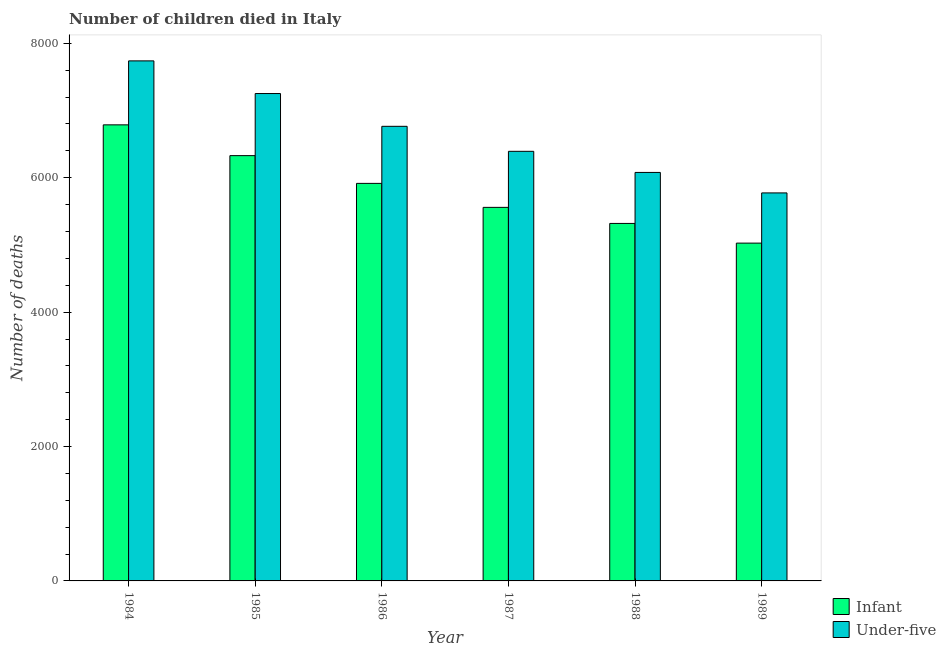How many groups of bars are there?
Offer a very short reply. 6. Are the number of bars per tick equal to the number of legend labels?
Give a very brief answer. Yes. Are the number of bars on each tick of the X-axis equal?
Provide a short and direct response. Yes. What is the label of the 1st group of bars from the left?
Your answer should be very brief. 1984. What is the number of infant deaths in 1989?
Your response must be concise. 5027. Across all years, what is the maximum number of infant deaths?
Offer a terse response. 6787. Across all years, what is the minimum number of under-five deaths?
Your answer should be very brief. 5774. In which year was the number of under-five deaths maximum?
Provide a succinct answer. 1984. In which year was the number of infant deaths minimum?
Your response must be concise. 1989. What is the total number of infant deaths in the graph?
Your response must be concise. 3.49e+04. What is the difference between the number of infant deaths in 1986 and that in 1988?
Offer a terse response. 596. What is the difference between the number of infant deaths in 1985 and the number of under-five deaths in 1986?
Offer a very short reply. 413. What is the average number of infant deaths per year?
Offer a very short reply. 5823. In how many years, is the number of infant deaths greater than 5200?
Provide a short and direct response. 5. What is the ratio of the number of under-five deaths in 1987 to that in 1989?
Provide a succinct answer. 1.11. Is the number of infant deaths in 1988 less than that in 1989?
Ensure brevity in your answer.  No. What is the difference between the highest and the second highest number of infant deaths?
Provide a succinct answer. 458. What is the difference between the highest and the lowest number of infant deaths?
Your response must be concise. 1760. What does the 2nd bar from the left in 1984 represents?
Your answer should be very brief. Under-five. What does the 1st bar from the right in 1989 represents?
Offer a very short reply. Under-five. How many bars are there?
Give a very brief answer. 12. Does the graph contain any zero values?
Your answer should be very brief. No. Where does the legend appear in the graph?
Make the answer very short. Bottom right. How many legend labels are there?
Your answer should be very brief. 2. What is the title of the graph?
Offer a very short reply. Number of children died in Italy. What is the label or title of the X-axis?
Make the answer very short. Year. What is the label or title of the Y-axis?
Provide a succinct answer. Number of deaths. What is the Number of deaths of Infant in 1984?
Keep it short and to the point. 6787. What is the Number of deaths of Under-five in 1984?
Offer a terse response. 7739. What is the Number of deaths of Infant in 1985?
Make the answer very short. 6329. What is the Number of deaths of Under-five in 1985?
Give a very brief answer. 7253. What is the Number of deaths in Infant in 1986?
Offer a terse response. 5916. What is the Number of deaths in Under-five in 1986?
Offer a terse response. 6765. What is the Number of deaths in Infant in 1987?
Ensure brevity in your answer.  5559. What is the Number of deaths of Under-five in 1987?
Your answer should be compact. 6393. What is the Number of deaths of Infant in 1988?
Offer a terse response. 5320. What is the Number of deaths of Under-five in 1988?
Give a very brief answer. 6079. What is the Number of deaths in Infant in 1989?
Offer a very short reply. 5027. What is the Number of deaths of Under-five in 1989?
Provide a succinct answer. 5774. Across all years, what is the maximum Number of deaths in Infant?
Provide a succinct answer. 6787. Across all years, what is the maximum Number of deaths in Under-five?
Your response must be concise. 7739. Across all years, what is the minimum Number of deaths of Infant?
Give a very brief answer. 5027. Across all years, what is the minimum Number of deaths of Under-five?
Your answer should be very brief. 5774. What is the total Number of deaths of Infant in the graph?
Your answer should be compact. 3.49e+04. What is the total Number of deaths of Under-five in the graph?
Ensure brevity in your answer.  4.00e+04. What is the difference between the Number of deaths of Infant in 1984 and that in 1985?
Keep it short and to the point. 458. What is the difference between the Number of deaths in Under-five in 1984 and that in 1985?
Ensure brevity in your answer.  486. What is the difference between the Number of deaths in Infant in 1984 and that in 1986?
Give a very brief answer. 871. What is the difference between the Number of deaths of Under-five in 1984 and that in 1986?
Keep it short and to the point. 974. What is the difference between the Number of deaths in Infant in 1984 and that in 1987?
Keep it short and to the point. 1228. What is the difference between the Number of deaths of Under-five in 1984 and that in 1987?
Offer a terse response. 1346. What is the difference between the Number of deaths of Infant in 1984 and that in 1988?
Provide a succinct answer. 1467. What is the difference between the Number of deaths of Under-five in 1984 and that in 1988?
Give a very brief answer. 1660. What is the difference between the Number of deaths of Infant in 1984 and that in 1989?
Offer a very short reply. 1760. What is the difference between the Number of deaths in Under-five in 1984 and that in 1989?
Make the answer very short. 1965. What is the difference between the Number of deaths of Infant in 1985 and that in 1986?
Make the answer very short. 413. What is the difference between the Number of deaths of Under-five in 1985 and that in 1986?
Offer a very short reply. 488. What is the difference between the Number of deaths of Infant in 1985 and that in 1987?
Offer a very short reply. 770. What is the difference between the Number of deaths of Under-five in 1985 and that in 1987?
Give a very brief answer. 860. What is the difference between the Number of deaths of Infant in 1985 and that in 1988?
Offer a very short reply. 1009. What is the difference between the Number of deaths of Under-five in 1985 and that in 1988?
Give a very brief answer. 1174. What is the difference between the Number of deaths of Infant in 1985 and that in 1989?
Provide a short and direct response. 1302. What is the difference between the Number of deaths in Under-five in 1985 and that in 1989?
Your response must be concise. 1479. What is the difference between the Number of deaths of Infant in 1986 and that in 1987?
Your answer should be very brief. 357. What is the difference between the Number of deaths in Under-five in 1986 and that in 1987?
Keep it short and to the point. 372. What is the difference between the Number of deaths in Infant in 1986 and that in 1988?
Offer a very short reply. 596. What is the difference between the Number of deaths in Under-five in 1986 and that in 1988?
Ensure brevity in your answer.  686. What is the difference between the Number of deaths of Infant in 1986 and that in 1989?
Your response must be concise. 889. What is the difference between the Number of deaths in Under-five in 1986 and that in 1989?
Make the answer very short. 991. What is the difference between the Number of deaths in Infant in 1987 and that in 1988?
Keep it short and to the point. 239. What is the difference between the Number of deaths in Under-five in 1987 and that in 1988?
Your answer should be very brief. 314. What is the difference between the Number of deaths in Infant in 1987 and that in 1989?
Your answer should be compact. 532. What is the difference between the Number of deaths in Under-five in 1987 and that in 1989?
Offer a terse response. 619. What is the difference between the Number of deaths of Infant in 1988 and that in 1989?
Make the answer very short. 293. What is the difference between the Number of deaths in Under-five in 1988 and that in 1989?
Your response must be concise. 305. What is the difference between the Number of deaths in Infant in 1984 and the Number of deaths in Under-five in 1985?
Offer a very short reply. -466. What is the difference between the Number of deaths in Infant in 1984 and the Number of deaths in Under-five in 1987?
Your answer should be compact. 394. What is the difference between the Number of deaths in Infant in 1984 and the Number of deaths in Under-five in 1988?
Your response must be concise. 708. What is the difference between the Number of deaths in Infant in 1984 and the Number of deaths in Under-five in 1989?
Ensure brevity in your answer.  1013. What is the difference between the Number of deaths of Infant in 1985 and the Number of deaths of Under-five in 1986?
Give a very brief answer. -436. What is the difference between the Number of deaths in Infant in 1985 and the Number of deaths in Under-five in 1987?
Your answer should be very brief. -64. What is the difference between the Number of deaths in Infant in 1985 and the Number of deaths in Under-five in 1988?
Offer a terse response. 250. What is the difference between the Number of deaths in Infant in 1985 and the Number of deaths in Under-five in 1989?
Your answer should be very brief. 555. What is the difference between the Number of deaths in Infant in 1986 and the Number of deaths in Under-five in 1987?
Your answer should be compact. -477. What is the difference between the Number of deaths of Infant in 1986 and the Number of deaths of Under-five in 1988?
Ensure brevity in your answer.  -163. What is the difference between the Number of deaths of Infant in 1986 and the Number of deaths of Under-five in 1989?
Provide a short and direct response. 142. What is the difference between the Number of deaths in Infant in 1987 and the Number of deaths in Under-five in 1988?
Offer a very short reply. -520. What is the difference between the Number of deaths of Infant in 1987 and the Number of deaths of Under-five in 1989?
Your answer should be compact. -215. What is the difference between the Number of deaths of Infant in 1988 and the Number of deaths of Under-five in 1989?
Your answer should be compact. -454. What is the average Number of deaths of Infant per year?
Your response must be concise. 5823. What is the average Number of deaths in Under-five per year?
Offer a very short reply. 6667.17. In the year 1984, what is the difference between the Number of deaths in Infant and Number of deaths in Under-five?
Your answer should be compact. -952. In the year 1985, what is the difference between the Number of deaths in Infant and Number of deaths in Under-five?
Give a very brief answer. -924. In the year 1986, what is the difference between the Number of deaths in Infant and Number of deaths in Under-five?
Your answer should be very brief. -849. In the year 1987, what is the difference between the Number of deaths of Infant and Number of deaths of Under-five?
Provide a succinct answer. -834. In the year 1988, what is the difference between the Number of deaths of Infant and Number of deaths of Under-five?
Offer a terse response. -759. In the year 1989, what is the difference between the Number of deaths in Infant and Number of deaths in Under-five?
Give a very brief answer. -747. What is the ratio of the Number of deaths of Infant in 1984 to that in 1985?
Make the answer very short. 1.07. What is the ratio of the Number of deaths in Under-five in 1984 to that in 1985?
Make the answer very short. 1.07. What is the ratio of the Number of deaths of Infant in 1984 to that in 1986?
Your answer should be compact. 1.15. What is the ratio of the Number of deaths in Under-five in 1984 to that in 1986?
Provide a succinct answer. 1.14. What is the ratio of the Number of deaths in Infant in 1984 to that in 1987?
Provide a short and direct response. 1.22. What is the ratio of the Number of deaths in Under-five in 1984 to that in 1987?
Your answer should be very brief. 1.21. What is the ratio of the Number of deaths in Infant in 1984 to that in 1988?
Your answer should be very brief. 1.28. What is the ratio of the Number of deaths in Under-five in 1984 to that in 1988?
Your answer should be compact. 1.27. What is the ratio of the Number of deaths in Infant in 1984 to that in 1989?
Give a very brief answer. 1.35. What is the ratio of the Number of deaths in Under-five in 1984 to that in 1989?
Offer a very short reply. 1.34. What is the ratio of the Number of deaths of Infant in 1985 to that in 1986?
Your response must be concise. 1.07. What is the ratio of the Number of deaths in Under-five in 1985 to that in 1986?
Make the answer very short. 1.07. What is the ratio of the Number of deaths of Infant in 1985 to that in 1987?
Make the answer very short. 1.14. What is the ratio of the Number of deaths of Under-five in 1985 to that in 1987?
Provide a succinct answer. 1.13. What is the ratio of the Number of deaths of Infant in 1985 to that in 1988?
Keep it short and to the point. 1.19. What is the ratio of the Number of deaths in Under-five in 1985 to that in 1988?
Offer a terse response. 1.19. What is the ratio of the Number of deaths of Infant in 1985 to that in 1989?
Make the answer very short. 1.26. What is the ratio of the Number of deaths of Under-five in 1985 to that in 1989?
Your answer should be very brief. 1.26. What is the ratio of the Number of deaths in Infant in 1986 to that in 1987?
Your answer should be compact. 1.06. What is the ratio of the Number of deaths in Under-five in 1986 to that in 1987?
Your answer should be very brief. 1.06. What is the ratio of the Number of deaths in Infant in 1986 to that in 1988?
Make the answer very short. 1.11. What is the ratio of the Number of deaths in Under-five in 1986 to that in 1988?
Keep it short and to the point. 1.11. What is the ratio of the Number of deaths of Infant in 1986 to that in 1989?
Provide a succinct answer. 1.18. What is the ratio of the Number of deaths in Under-five in 1986 to that in 1989?
Offer a terse response. 1.17. What is the ratio of the Number of deaths of Infant in 1987 to that in 1988?
Offer a terse response. 1.04. What is the ratio of the Number of deaths in Under-five in 1987 to that in 1988?
Offer a very short reply. 1.05. What is the ratio of the Number of deaths in Infant in 1987 to that in 1989?
Give a very brief answer. 1.11. What is the ratio of the Number of deaths of Under-five in 1987 to that in 1989?
Your response must be concise. 1.11. What is the ratio of the Number of deaths in Infant in 1988 to that in 1989?
Provide a succinct answer. 1.06. What is the ratio of the Number of deaths of Under-five in 1988 to that in 1989?
Make the answer very short. 1.05. What is the difference between the highest and the second highest Number of deaths of Infant?
Your response must be concise. 458. What is the difference between the highest and the second highest Number of deaths in Under-five?
Ensure brevity in your answer.  486. What is the difference between the highest and the lowest Number of deaths of Infant?
Your answer should be very brief. 1760. What is the difference between the highest and the lowest Number of deaths in Under-five?
Make the answer very short. 1965. 